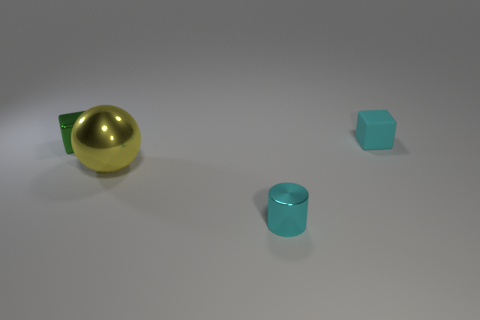Is there any other thing that is made of the same material as the cyan block?
Your answer should be very brief. No. What is the thing that is in front of the green object and left of the tiny cyan cylinder made of?
Provide a succinct answer. Metal. How many cubes are the same size as the cyan rubber object?
Your response must be concise. 1. There is another thing that is the same shape as the small cyan matte object; what material is it?
Ensure brevity in your answer.  Metal. What number of objects are either tiny metal objects behind the cyan metallic thing or blocks behind the green cube?
Your answer should be compact. 2. There is a rubber object; is its shape the same as the tiny shiny object that is behind the large metallic sphere?
Keep it short and to the point. Yes. The cyan object to the left of the block that is right of the tiny object that is in front of the small green metallic block is what shape?
Offer a very short reply. Cylinder. What number of other objects are the same material as the big sphere?
Provide a short and direct response. 2. How many objects are either tiny cyan objects in front of the tiny metal block or small rubber things?
Provide a succinct answer. 2. There is a tiny cyan thing that is on the left side of the small object that is behind the green metallic thing; what shape is it?
Your answer should be compact. Cylinder. 